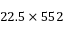Convert formula to latex. <formula><loc_0><loc_0><loc_500><loc_500>2 2 . 5 \times 5 5 2</formula> 